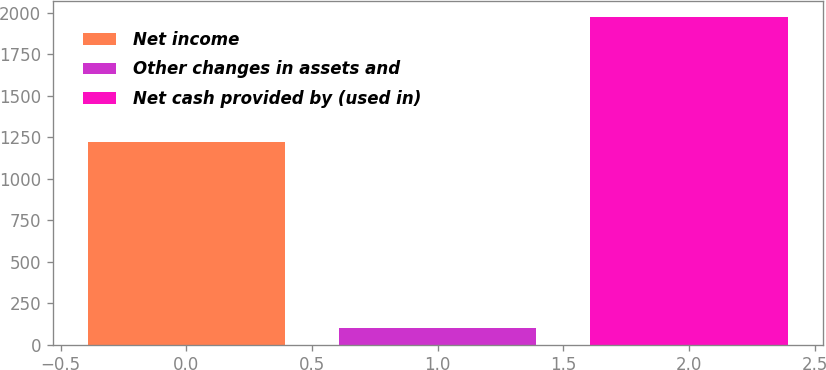Convert chart. <chart><loc_0><loc_0><loc_500><loc_500><bar_chart><fcel>Net income<fcel>Other changes in assets and<fcel>Net cash provided by (used in)<nl><fcel>1223<fcel>102.1<fcel>1973.3<nl></chart> 